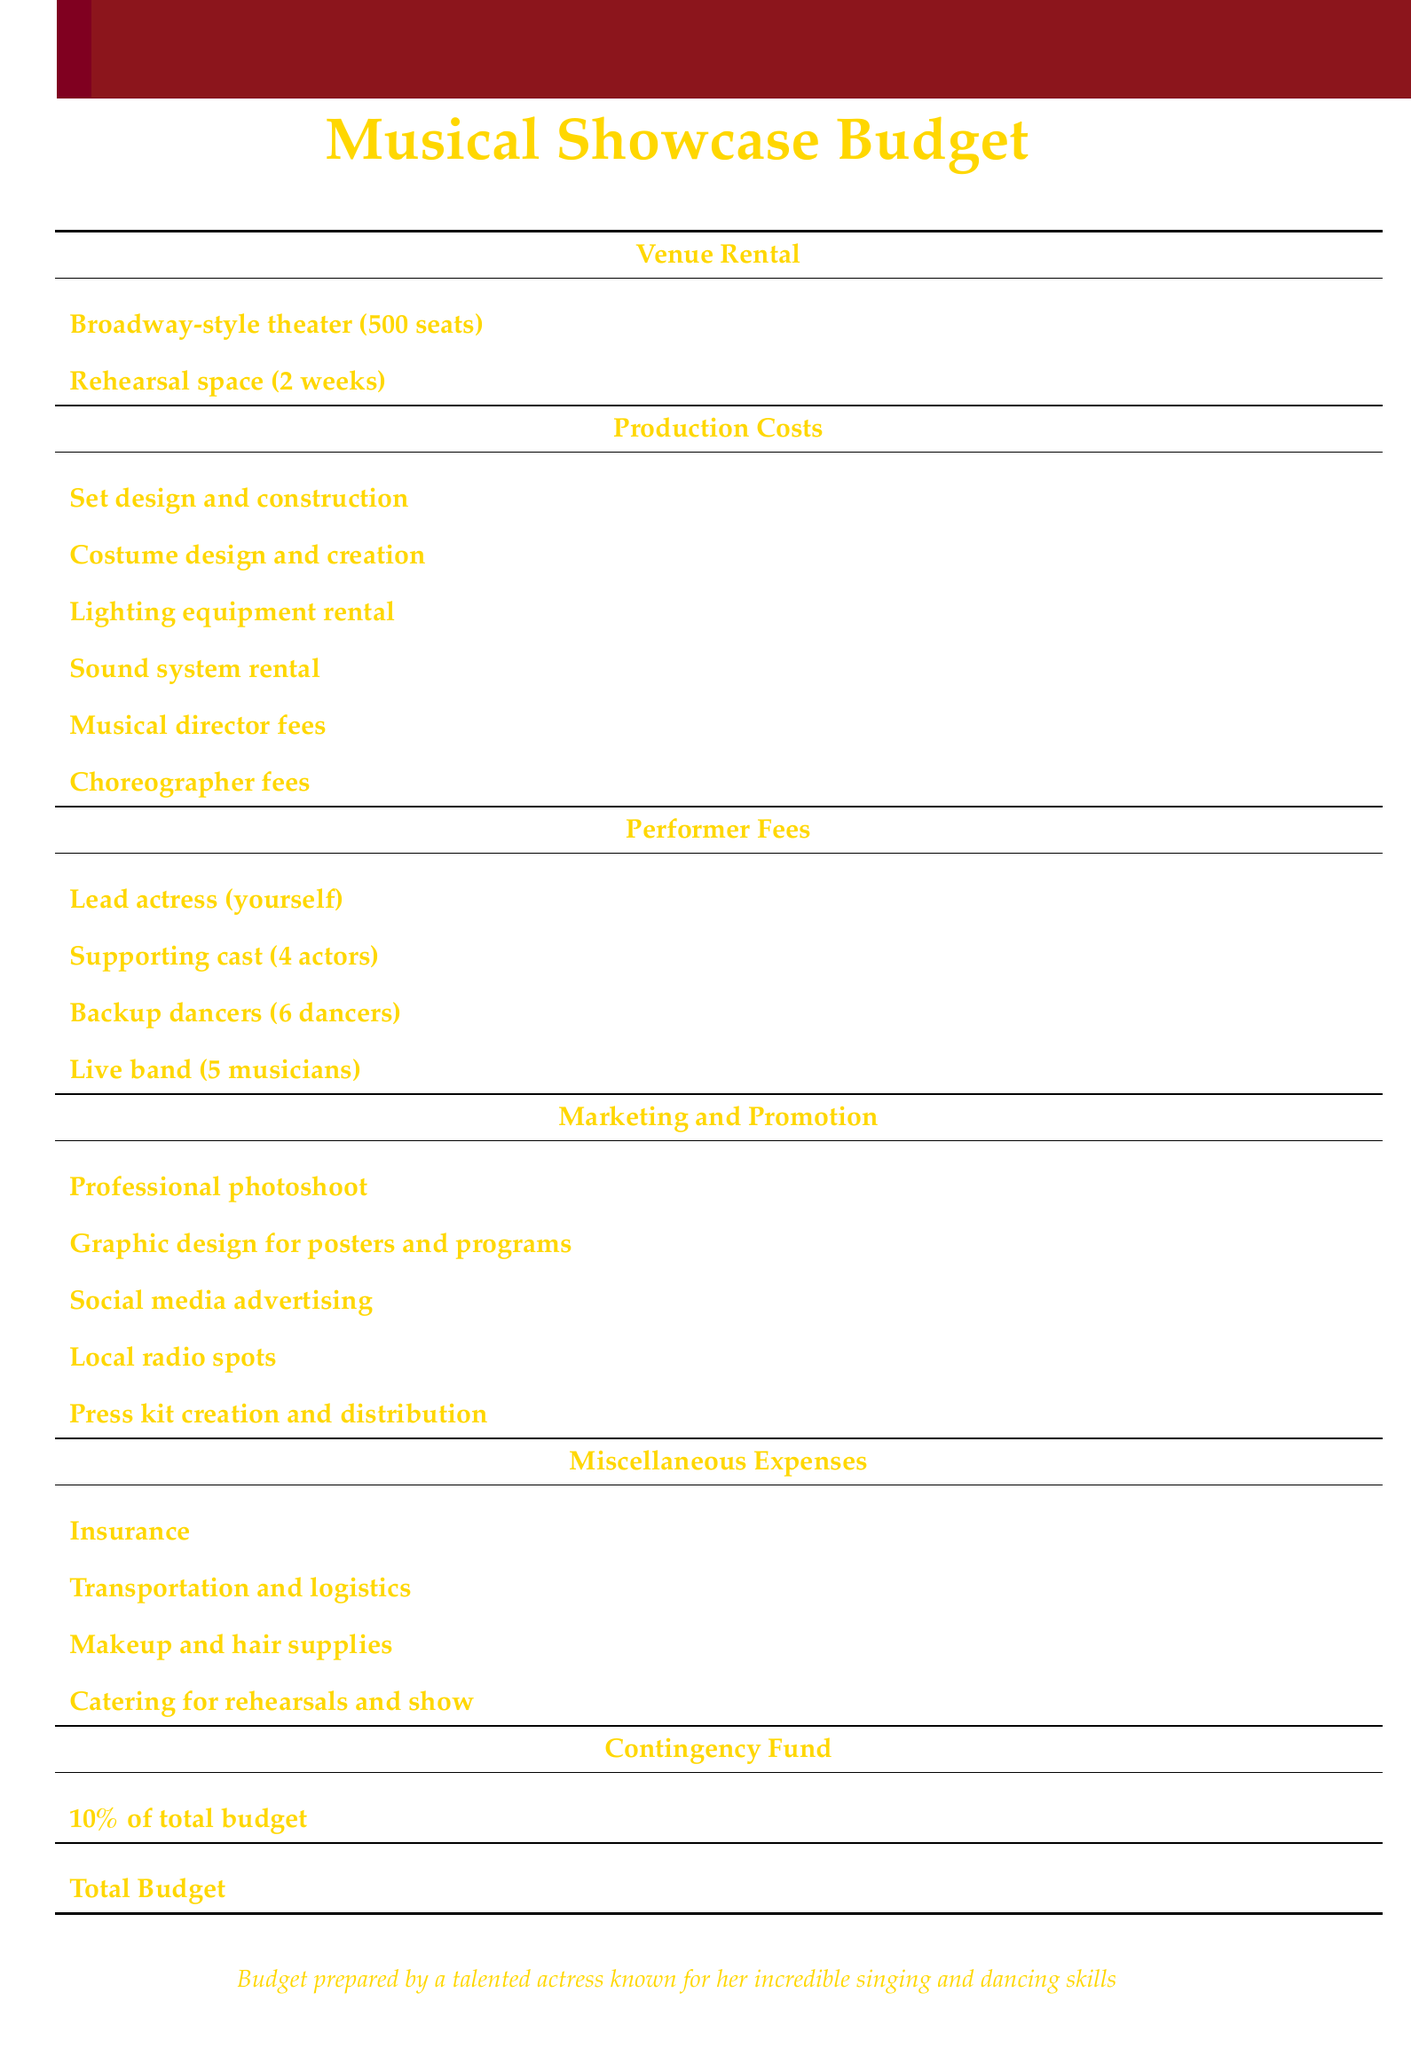What is the total budget? The total budget is listed at the bottom of the document, summarizing all expenses.
Answer: $65,780 How much is allocated for performer fees? The performer fees section lists the totals for various performers, which sum to $19,000.
Answer: $19,000 What is the cost of the Broadway-style theater rental? The specific cost for the Broadway-style theater rental is itemized in the venue rental section.
Answer: $5,000 How much does the live band cost? The cost of the live band is specified under performer fees in the document.
Answer: $5,000 What percentage is reserved for the contingency fund? The document indicates that the contingency fund is calculated as a percentage of the total budget.
Answer: 10% What is the total cost for marketing and promotion? The total cost for marketing and promotion can be found by adding the individual cost items listed in that section.
Answer: $6,800 How much does it cost to hire the musical director? The fee for the musical director is listed under production costs.
Answer: $3,500 What is the cost for social media advertising? The specific cost for social media advertising is detailed in the marketing and promotion section.
Answer: $2,000 How many backup dancers are included in the budget? The number of backup dancers is mentioned under the performer fees section of the document.
Answer: 6 dancers What is the expense for costume design? The expense for costume design is itemized under production costs.
Answer: $4,000 